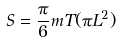<formula> <loc_0><loc_0><loc_500><loc_500>S = \frac { \pi } { 6 } m T ( \pi L ^ { 2 } )</formula> 